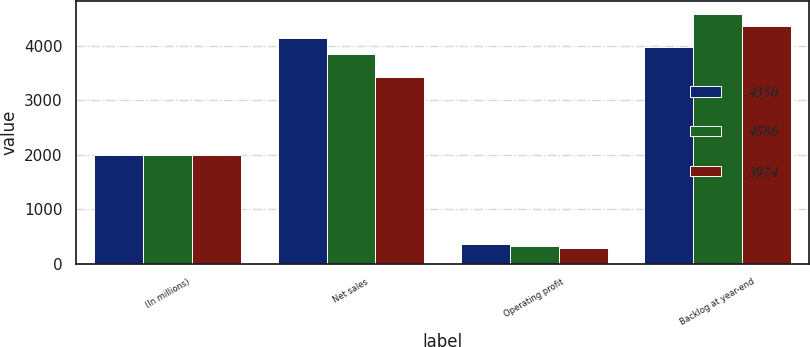<chart> <loc_0><loc_0><loc_500><loc_500><stacked_bar_chart><ecel><fcel>(In millions)<fcel>Net sales<fcel>Operating profit<fcel>Backlog at year-end<nl><fcel>4350<fcel>2005<fcel>4131<fcel>365<fcel>3974<nl><fcel>4586<fcel>2004<fcel>3851<fcel>334<fcel>4586<nl><fcel>3974<fcel>2003<fcel>3422<fcel>291<fcel>4350<nl></chart> 